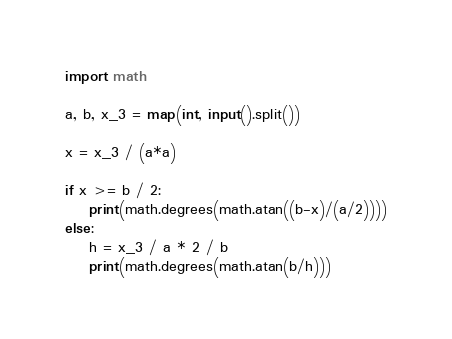<code> <loc_0><loc_0><loc_500><loc_500><_Python_>import math

a, b, x_3 = map(int, input().split())

x = x_3 / (a*a)

if x >= b / 2:
    print(math.degrees(math.atan((b-x)/(a/2))))
else:
    h = x_3 / a * 2 / b
    print(math.degrees(math.atan(b/h)))</code> 